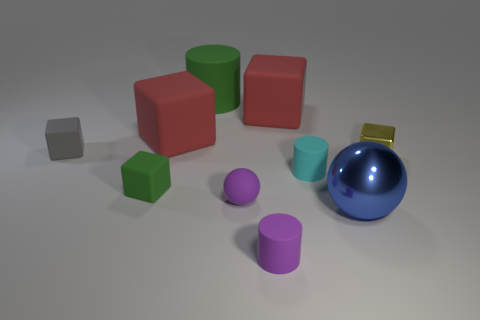Are there the same number of tiny balls behind the small cyan matte object and green rubber things?
Make the answer very short. No. Is there anything else that has the same material as the purple cylinder?
Offer a terse response. Yes. Does the green object behind the tiny green rubber cube have the same material as the purple sphere?
Make the answer very short. Yes. Is the number of rubber cylinders that are in front of the green matte cylinder less than the number of red cylinders?
Provide a short and direct response. No. What number of rubber objects are either cylinders or tiny gray objects?
Your answer should be compact. 4. Is the big metal sphere the same color as the metallic cube?
Offer a very short reply. No. Is there anything else of the same color as the tiny shiny thing?
Offer a very short reply. No. There is a green matte thing that is on the left side of the large matte cylinder; is it the same shape as the large red object that is to the right of the purple rubber sphere?
Provide a short and direct response. Yes. What number of things are either big gray blocks or tiny things in front of the small gray rubber thing?
Provide a short and direct response. 5. What number of other things are there of the same size as the cyan rubber cylinder?
Provide a short and direct response. 5. 